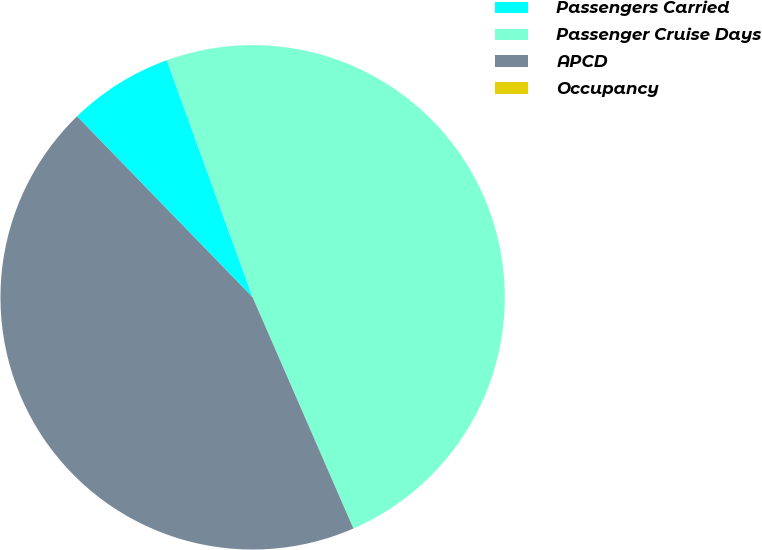Convert chart. <chart><loc_0><loc_0><loc_500><loc_500><pie_chart><fcel>Passengers Carried<fcel>Passenger Cruise Days<fcel>APCD<fcel>Occupancy<nl><fcel>6.73%<fcel>48.99%<fcel>44.28%<fcel>0.0%<nl></chart> 